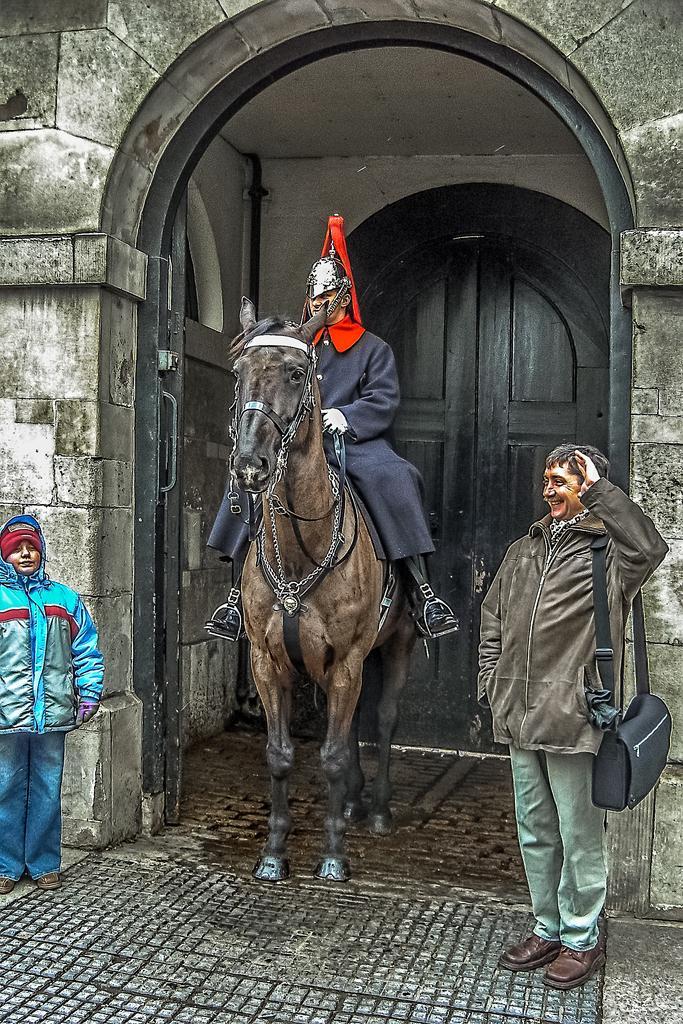Please provide a concise description of this image. In this image we can see a man sitting on the horse and two people are standing beside him. In the background we can see a door and a wall. 